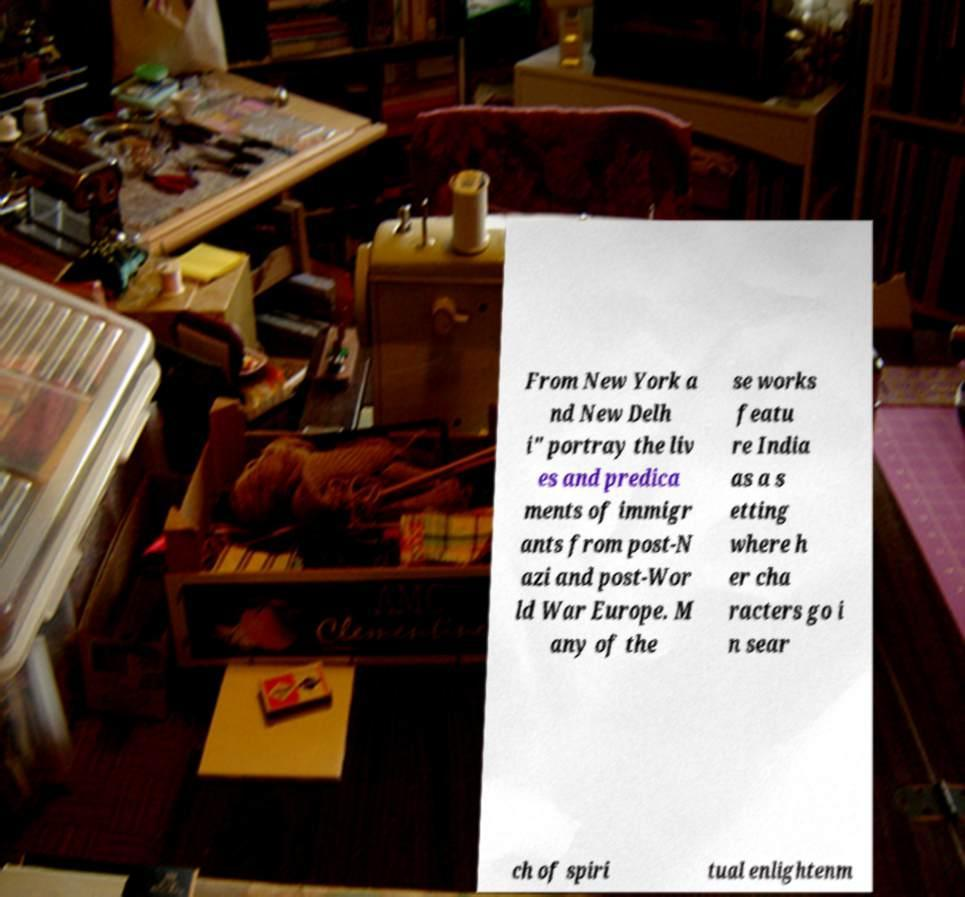Can you read and provide the text displayed in the image?This photo seems to have some interesting text. Can you extract and type it out for me? From New York a nd New Delh i" portray the liv es and predica ments of immigr ants from post-N azi and post-Wor ld War Europe. M any of the se works featu re India as a s etting where h er cha racters go i n sear ch of spiri tual enlightenm 